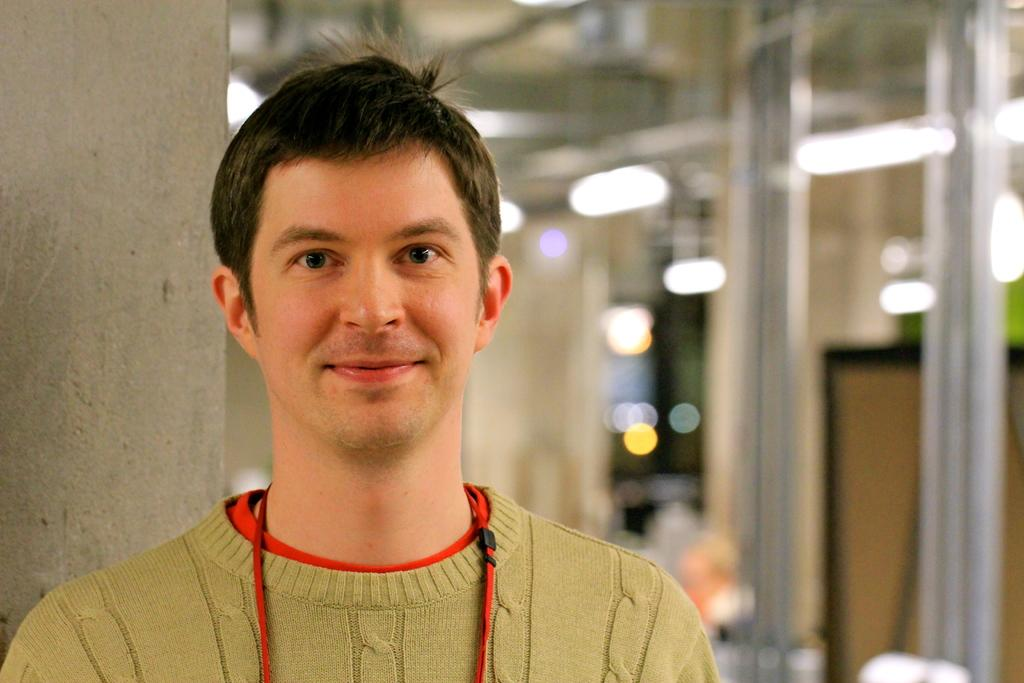What is the main subject of the image? There is a man in the image. What is the man's facial expression? The man is smiling. Can you describe the background of the image? The background of the image is blurry. What type of drink is the man holding in the image? There is no drink visible in the image; the man is not holding anything. 